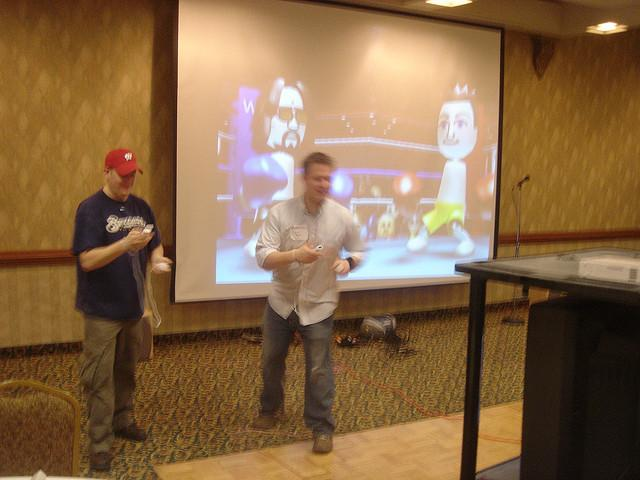Which player is controlling the avatar with the blue gloves?

Choices:
A) black shirt
B) off screen
C) dress shirt
D) blue jeans black shirt 